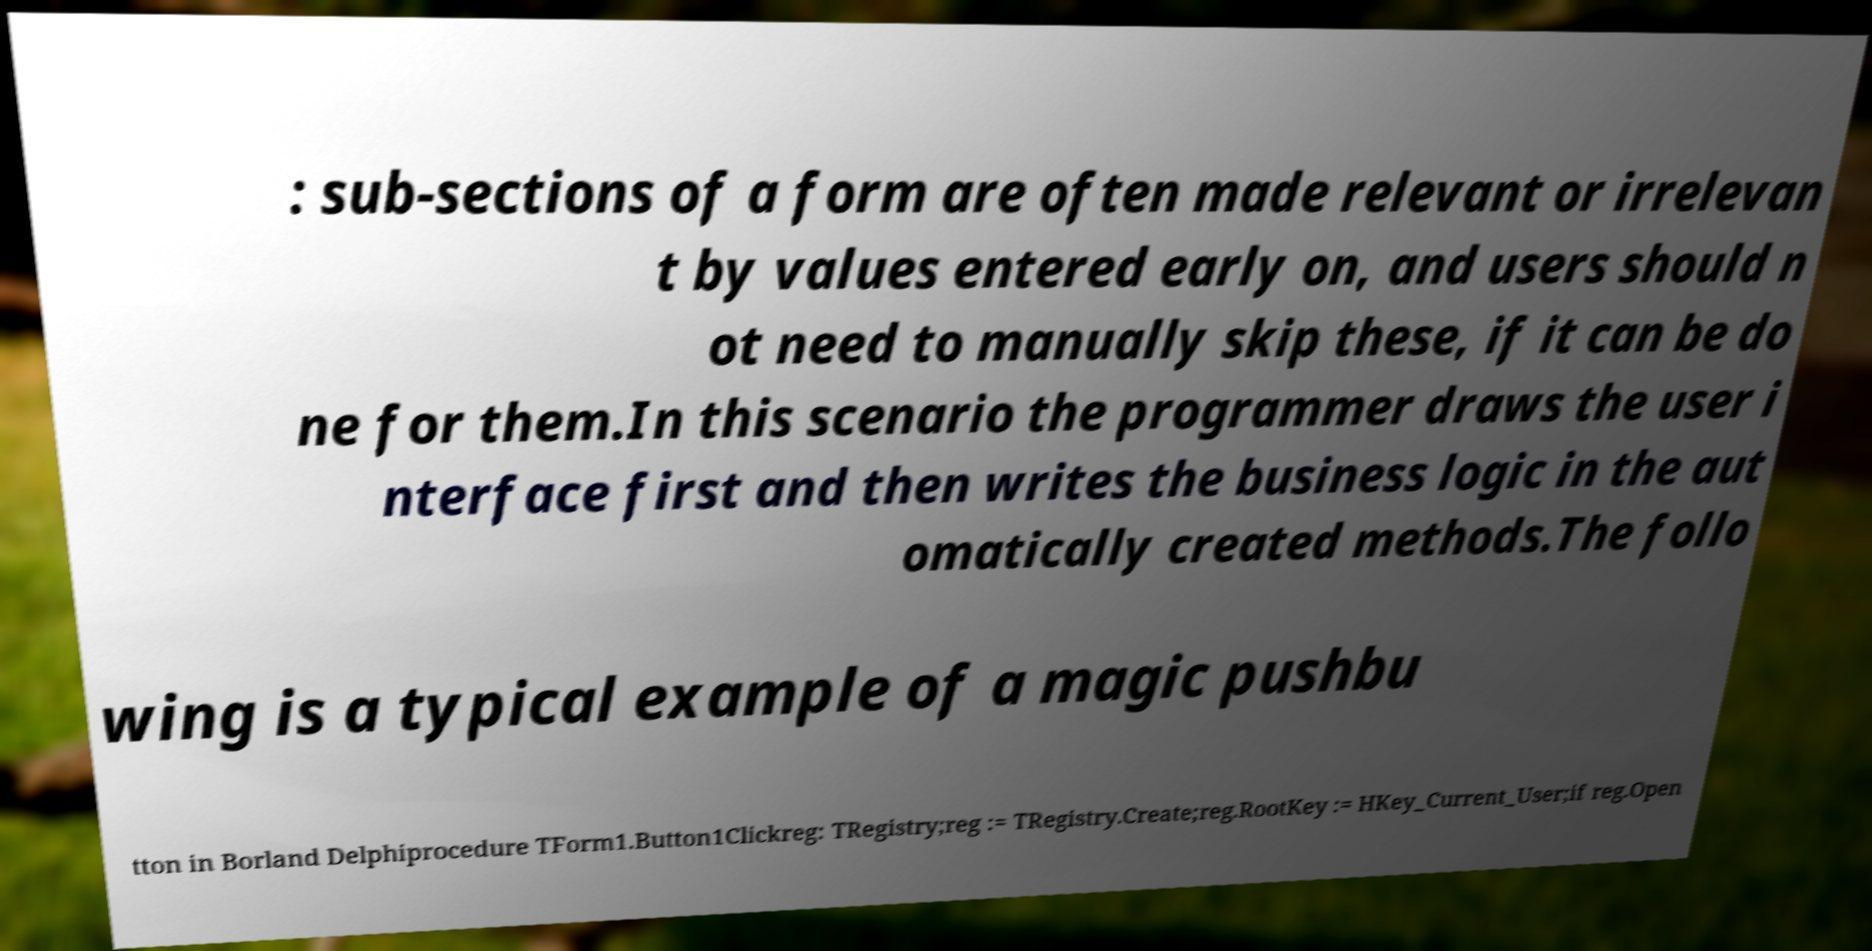For documentation purposes, I need the text within this image transcribed. Could you provide that? : sub-sections of a form are often made relevant or irrelevan t by values entered early on, and users should n ot need to manually skip these, if it can be do ne for them.In this scenario the programmer draws the user i nterface first and then writes the business logic in the aut omatically created methods.The follo wing is a typical example of a magic pushbu tton in Borland Delphiprocedure TForm1.Button1Clickreg: TRegistry;reg := TRegistry.Create;reg.RootKey := HKey_Current_User;if reg.Open 